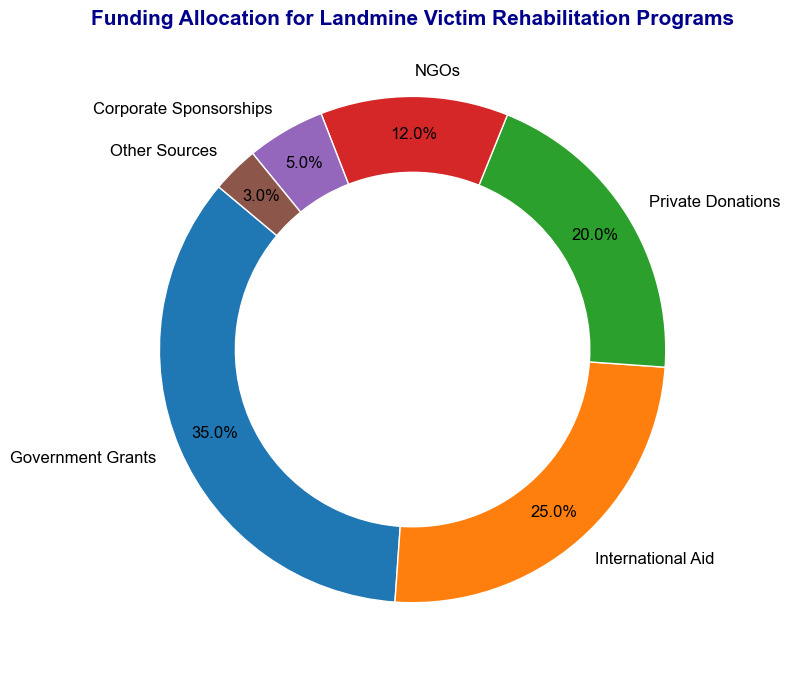What percentage of the funding comes from government grants? Look at the section labeled "Government Grants" on the ring chart, which shows the percentage allocation.
Answer: 35% Which funding source contributes the least to the total funding? Identify the section with the smallest percentage allocation. The smallest allocation is labeled "Other Sources."
Answer: Other Sources What is the combined funding percentage from Private Donations and NGOs? Check the percentages for "Private Donations" and "NGOs," which are 20% and 12%, respectively. Add these together for the combined funding percentage. 20% + 12% = 32%
Answer: 32% How does the funding from International Aid compare to Corporate Sponsorships? Compare the percentage allocations for "International Aid" and "Corporate Sponsorships." International Aid has 25%, while Corporate Sponsorships have 5%.
Answer: International Aid is higher What is the difference in funding percentages between Government Grants and Private Donations? Find the percentage for "Government Grants" (35%) and "Private Donations" (20%). Subtract these two percentages. 35% - 20% = 15%
Answer: 15% How much more funding is allocated to Government Grants than to NGOs? Compare the percentage allocations for "Government Grants" (35%) and "NGOs" (12%). Subtract these percentages. 35% - 12% = 23%
Answer: 23% What can you infer if Corporate Sponsorships and Other Sources are grouped together? Combine the percentages of "Corporate Sponsorships" (5%) and "Other Sources" (3%). 5% + 3% = 8%. This combined allocation is still less than any of the other individual categories.
Answer: 8%, still less than major categories Which category receives funding closest to 20%? Look at the chart segments' percentages and identify the one closest to 20%. "Private Donations" is exactly 20%.
Answer: Private Donations What is the total percentage of funding from sources other than Government Grants and International Aid? Subtract the sum of Government Grants (35%) and International Aid (25%) from 100%. 100% - (35% + 25%) = 40%
Answer: 40% Is the funding from Private Donations less than that from International Aid? Compare the percentages labeled "Private Donations" (20%) and "International Aid" (25%). Private Donations are less.
Answer: Yes 